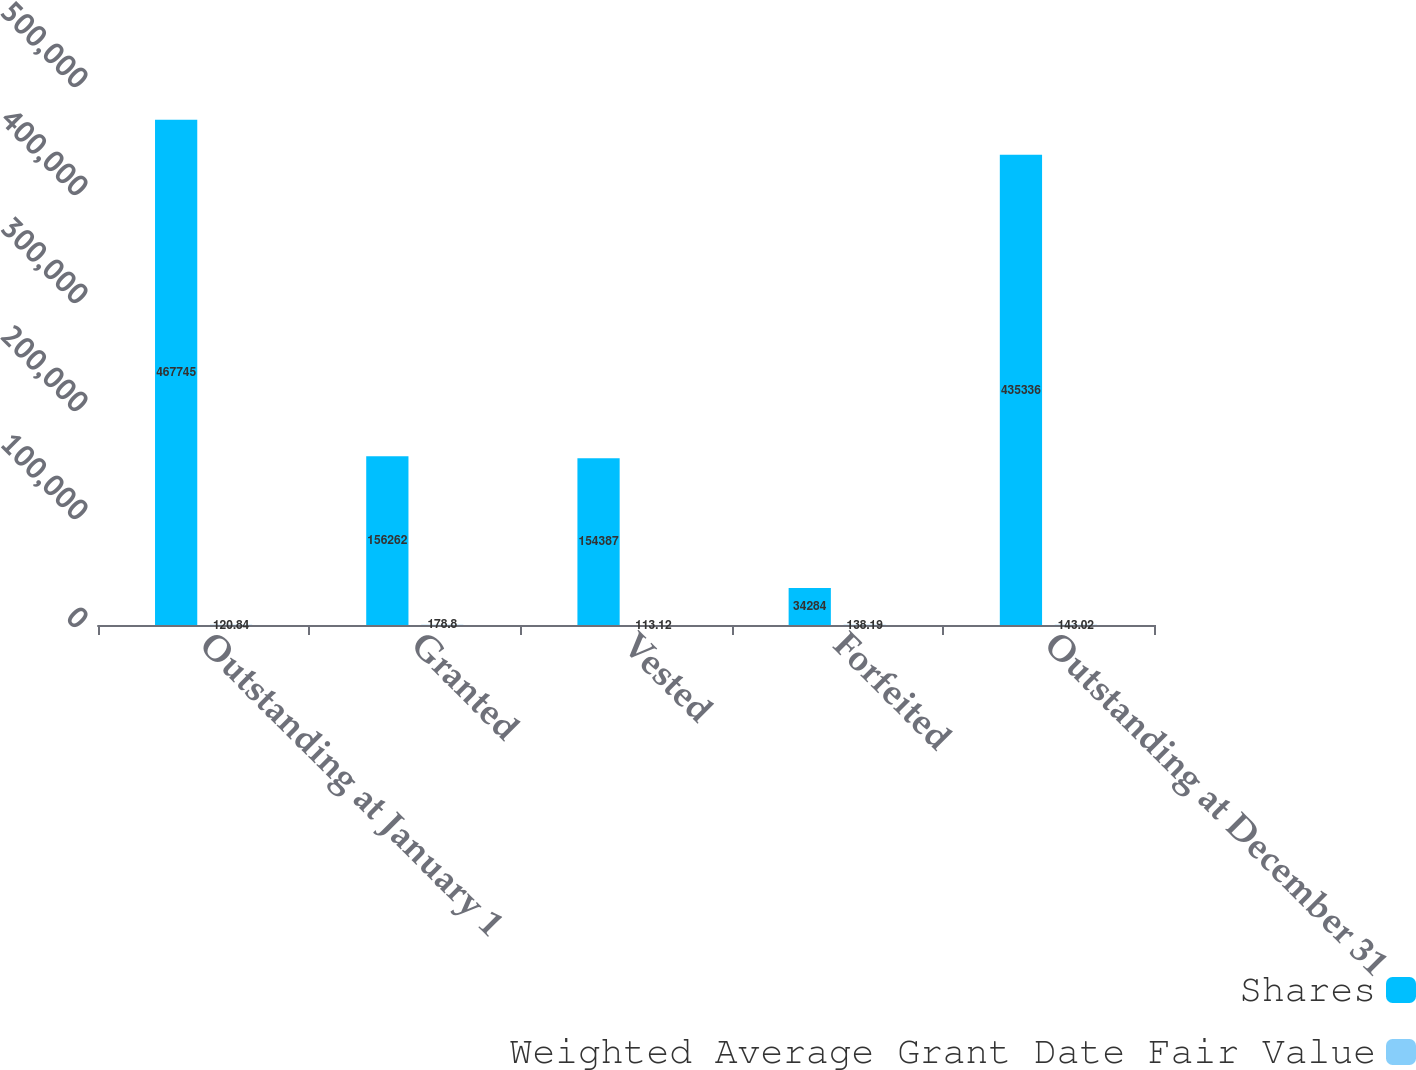Convert chart. <chart><loc_0><loc_0><loc_500><loc_500><stacked_bar_chart><ecel><fcel>Outstanding at January 1<fcel>Granted<fcel>Vested<fcel>Forfeited<fcel>Outstanding at December 31<nl><fcel>Shares<fcel>467745<fcel>156262<fcel>154387<fcel>34284<fcel>435336<nl><fcel>Weighted Average Grant Date Fair Value<fcel>120.84<fcel>178.8<fcel>113.12<fcel>138.19<fcel>143.02<nl></chart> 